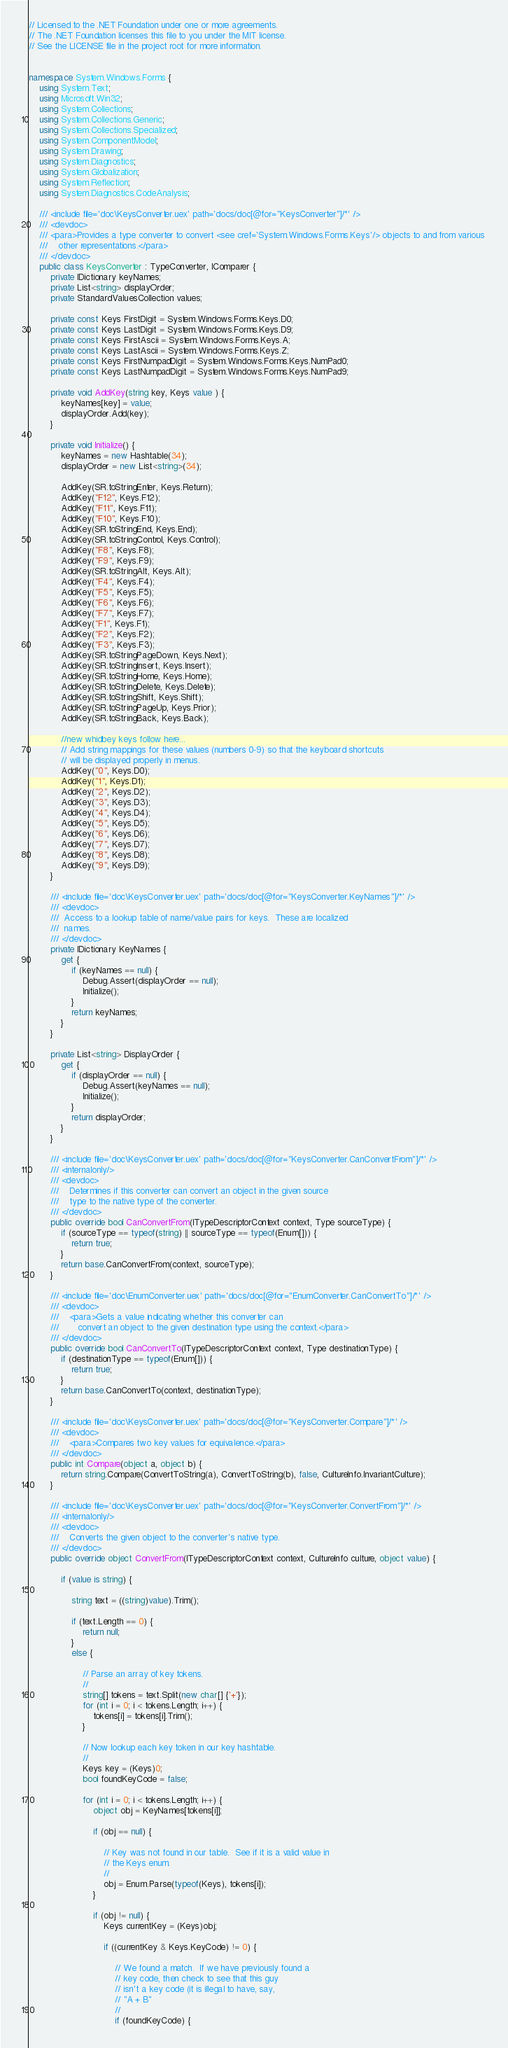Convert code to text. <code><loc_0><loc_0><loc_500><loc_500><_C#_>// Licensed to the .NET Foundation under one or more agreements.
// The .NET Foundation licenses this file to you under the MIT license.
// See the LICENSE file in the project root for more information.


namespace System.Windows.Forms {
    using System.Text;
    using Microsoft.Win32;
    using System.Collections;
    using System.Collections.Generic;
    using System.Collections.Specialized;
    using System.ComponentModel;
    using System.Drawing;
    using System.Diagnostics;
    using System.Globalization;
    using System.Reflection;
    using System.Diagnostics.CodeAnalysis;

    /// <include file='doc\KeysConverter.uex' path='docs/doc[@for="KeysConverter"]/*' />
    /// <devdoc>
    /// <para>Provides a type converter to convert <see cref='System.Windows.Forms.Keys'/> objects to and from various 
    ///    other representations.</para>
    /// </devdoc>
    public class KeysConverter : TypeConverter, IComparer {
        private IDictionary keyNames;
        private List<string> displayOrder;
        private StandardValuesCollection values;
    
        private const Keys FirstDigit = System.Windows.Forms.Keys.D0;
        private const Keys LastDigit = System.Windows.Forms.Keys.D9;
        private const Keys FirstAscii = System.Windows.Forms.Keys.A;
        private const Keys LastAscii = System.Windows.Forms.Keys.Z;
        private const Keys FirstNumpadDigit = System.Windows.Forms.Keys.NumPad0;
        private const Keys LastNumpadDigit = System.Windows.Forms.Keys.NumPad9;

        private void AddKey(string key, Keys value ) {
            keyNames[key] = value;
            displayOrder.Add(key);
        }

        private void Initialize() {
            keyNames = new Hashtable(34);
            displayOrder = new List<string>(34);

            AddKey(SR.toStringEnter, Keys.Return);
            AddKey("F12", Keys.F12);
            AddKey("F11", Keys.F11);
            AddKey("F10", Keys.F10);
            AddKey(SR.toStringEnd, Keys.End);
            AddKey(SR.toStringControl, Keys.Control);
            AddKey("F8", Keys.F8);
            AddKey("F9", Keys.F9);
            AddKey(SR.toStringAlt, Keys.Alt);
            AddKey("F4", Keys.F4);
            AddKey("F5", Keys.F5);
            AddKey("F6", Keys.F6);
            AddKey("F7", Keys.F7);
            AddKey("F1", Keys.F1);
            AddKey("F2", Keys.F2);
            AddKey("F3", Keys.F3);
            AddKey(SR.toStringPageDown, Keys.Next);
            AddKey(SR.toStringInsert, Keys.Insert);
            AddKey(SR.toStringHome, Keys.Home);
            AddKey(SR.toStringDelete, Keys.Delete);
            AddKey(SR.toStringShift, Keys.Shift);
            AddKey(SR.toStringPageUp, Keys.Prior);
            AddKey(SR.toStringBack, Keys.Back);

            //new whidbey keys follow here...
            // Add string mappings for these values (numbers 0-9) so that the keyboard shortcuts
            // will be displayed properly in menus.
            AddKey("0", Keys.D0);
            AddKey("1", Keys.D1);
            AddKey("2", Keys.D2);
            AddKey("3", Keys.D3);
            AddKey("4", Keys.D4);
            AddKey("5", Keys.D5);
            AddKey("6", Keys.D6);
            AddKey("7", Keys.D7);
            AddKey("8", Keys.D8);
            AddKey("9", Keys.D9);
        }

        /// <include file='doc\KeysConverter.uex' path='docs/doc[@for="KeysConverter.KeyNames"]/*' />
        /// <devdoc>
        ///  Access to a lookup table of name/value pairs for keys.  These are localized
        ///  names.
        /// </devdoc>
        private IDictionary KeyNames {
            get {
                if (keyNames == null) {
                    Debug.Assert(displayOrder == null);
                    Initialize();
                }
                return keyNames;
            }
        }

        private List<string> DisplayOrder {
            get {
                if (displayOrder == null) {
                    Debug.Assert(keyNames == null);
                    Initialize();
                }
                return displayOrder;
            }
        }
    
        /// <include file='doc\KeysConverter.uex' path='docs/doc[@for="KeysConverter.CanConvertFrom"]/*' />
        /// <internalonly/>
        /// <devdoc>
        ///    Determines if this converter can convert an object in the given source
        ///    type to the native type of the converter.
        /// </devdoc>
        public override bool CanConvertFrom(ITypeDescriptorContext context, Type sourceType) {
            if (sourceType == typeof(string) || sourceType == typeof(Enum[])) {
                return true;
            }
            return base.CanConvertFrom(context, sourceType);
        }
        
        /// <include file='doc\EnumConverter.uex' path='docs/doc[@for="EnumConverter.CanConvertTo"]/*' />
        /// <devdoc>
        ///    <para>Gets a value indicating whether this converter can
        ///       convert an object to the given destination type using the context.</para>
        /// </devdoc>
        public override bool CanConvertTo(ITypeDescriptorContext context, Type destinationType) {
            if (destinationType == typeof(Enum[])) {
                return true;
            }
            return base.CanConvertTo(context, destinationType);
        }

        /// <include file='doc\KeysConverter.uex' path='docs/doc[@for="KeysConverter.Compare"]/*' />
        /// <devdoc>
        ///    <para>Compares two key values for equivalence.</para>
        /// </devdoc>
        public int Compare(object a, object b) {
            return string.Compare(ConvertToString(a), ConvertToString(b), false, CultureInfo.InvariantCulture);
        }

        /// <include file='doc\KeysConverter.uex' path='docs/doc[@for="KeysConverter.ConvertFrom"]/*' />
        /// <internalonly/>
        /// <devdoc>
        ///    Converts the given object to the converter's native type.
        /// </devdoc>
        public override object ConvertFrom(ITypeDescriptorContext context, CultureInfo culture, object value) {
        
            if (value is string) {
            
                string text = ((string)value).Trim();
            
                if (text.Length == 0) {
                    return null;
                }
                else {
                
                    // Parse an array of key tokens.
                    //
                    string[] tokens = text.Split(new char[] {'+'});
                    for (int i = 0; i < tokens.Length; i++) {
                        tokens[i] = tokens[i].Trim();
                    }
                    
                    // Now lookup each key token in our key hashtable.
                    //
                    Keys key = (Keys)0;
                    bool foundKeyCode = false;
                    
                    for (int i = 0; i < tokens.Length; i++) {
                        object obj = KeyNames[tokens[i]];
                        
                        if (obj == null) {
                        
                            // Key was not found in our table.  See if it is a valid value in
                            // the Keys enum.
                            //
                            obj = Enum.Parse(typeof(Keys), tokens[i]);
                        }
                        
                        if (obj != null) {
                            Keys currentKey = (Keys)obj;
                            
                            if ((currentKey & Keys.KeyCode) != 0) {
                            
                                // We found a match.  If we have previously found a
                                // key code, then check to see that this guy
                                // isn't a key code (it is illegal to have, say,
                                // "A + B"
                                //
                                if (foundKeyCode) {</code> 